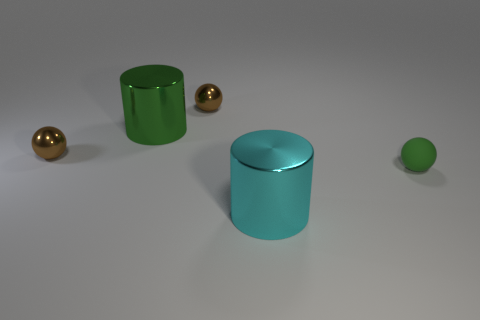Describe the color palette visible in the image. The color palette consists of cool and metallic tones. The two cylinders showcase rich green and teal colors, while the spheres have a golden hue that introduces warmth to the scene. The background is a neutral gray, which complements the objects without competing for attention. 